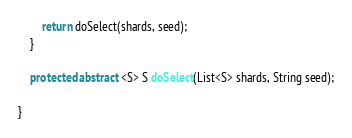Convert code to text. <code><loc_0><loc_0><loc_500><loc_500><_Java_>
        return doSelect(shards, seed);
    }

    protected abstract <S> S doSelect(List<S> shards, String seed);

}
</code> 